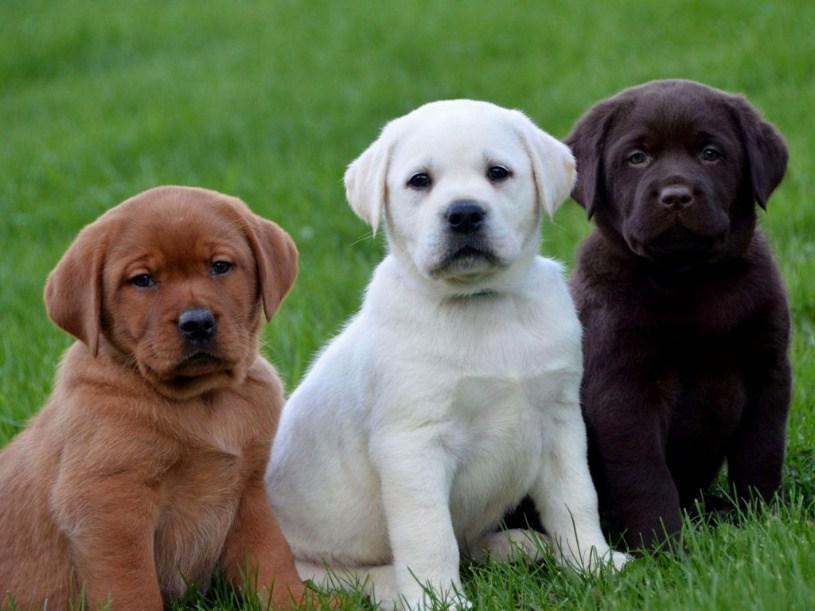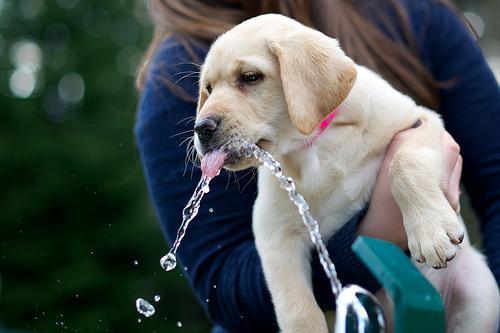The first image is the image on the left, the second image is the image on the right. Evaluate the accuracy of this statement regarding the images: "The dog in the grass in the image on the left has something to play with.". Is it true? Answer yes or no. No. 